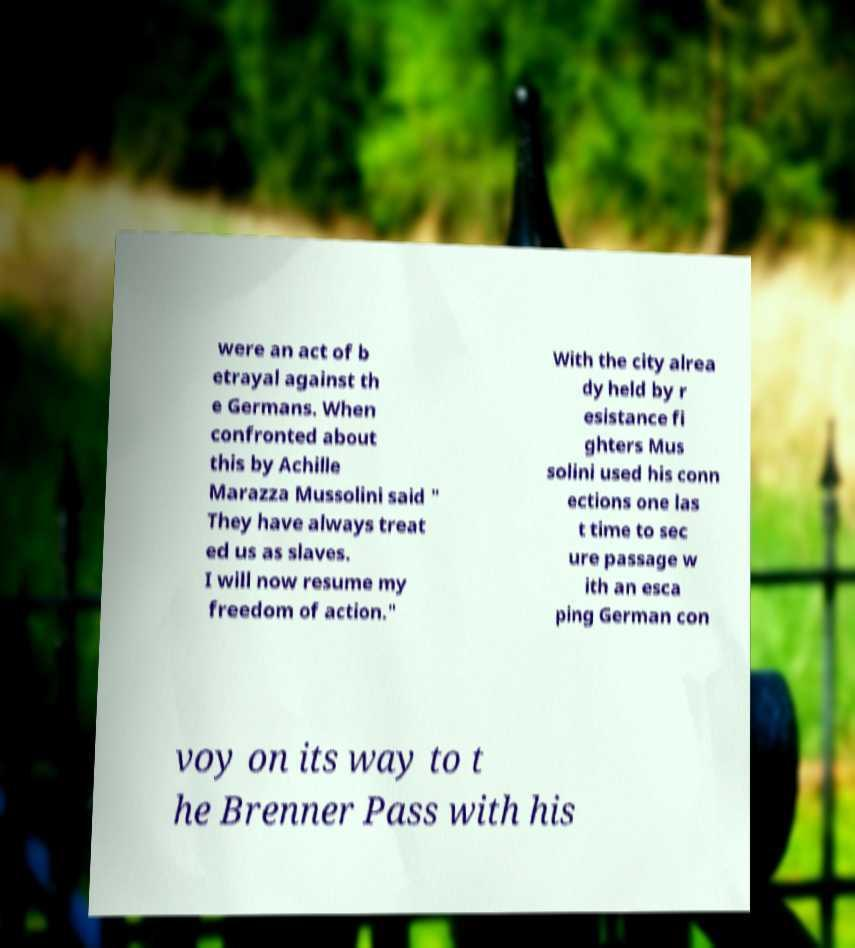Can you accurately transcribe the text from the provided image for me? were an act of b etrayal against th e Germans. When confronted about this by Achille Marazza Mussolini said " They have always treat ed us as slaves. I will now resume my freedom of action." With the city alrea dy held by r esistance fi ghters Mus solini used his conn ections one las t time to sec ure passage w ith an esca ping German con voy on its way to t he Brenner Pass with his 